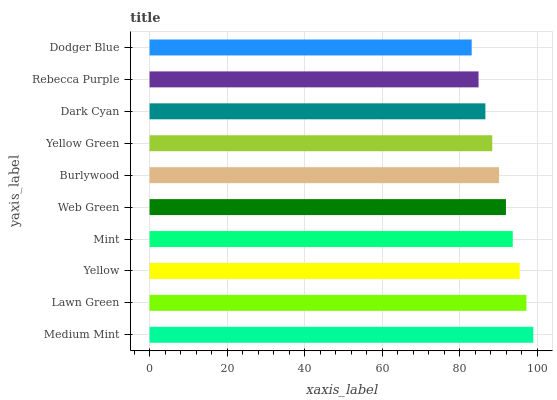Is Dodger Blue the minimum?
Answer yes or no. Yes. Is Medium Mint the maximum?
Answer yes or no. Yes. Is Lawn Green the minimum?
Answer yes or no. No. Is Lawn Green the maximum?
Answer yes or no. No. Is Medium Mint greater than Lawn Green?
Answer yes or no. Yes. Is Lawn Green less than Medium Mint?
Answer yes or no. Yes. Is Lawn Green greater than Medium Mint?
Answer yes or no. No. Is Medium Mint less than Lawn Green?
Answer yes or no. No. Is Web Green the high median?
Answer yes or no. Yes. Is Burlywood the low median?
Answer yes or no. Yes. Is Yellow the high median?
Answer yes or no. No. Is Rebecca Purple the low median?
Answer yes or no. No. 